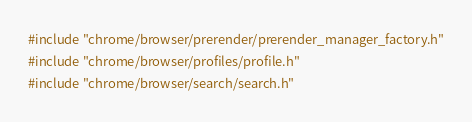Convert code to text. <code><loc_0><loc_0><loc_500><loc_500><_C++_>#include "chrome/browser/prerender/prerender_manager_factory.h"
#include "chrome/browser/profiles/profile.h"
#include "chrome/browser/search/search.h"</code> 